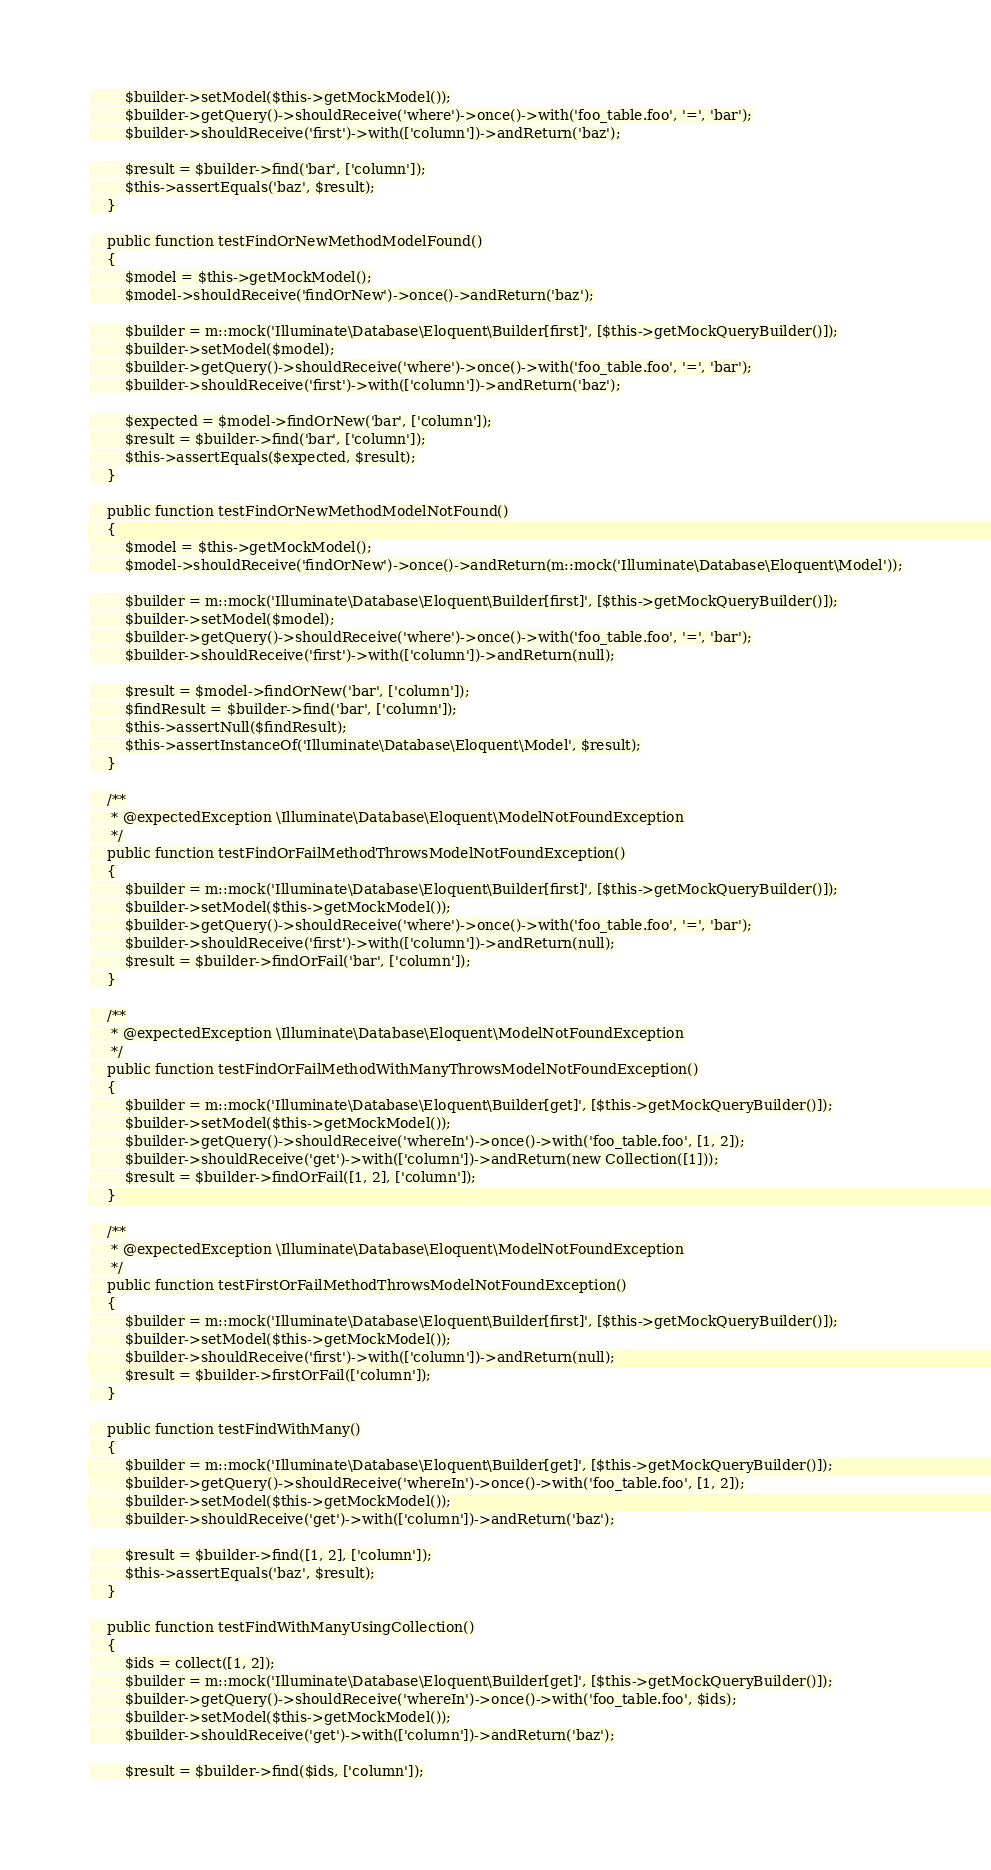<code> <loc_0><loc_0><loc_500><loc_500><_PHP_>        $builder->setModel($this->getMockModel());
        $builder->getQuery()->shouldReceive('where')->once()->with('foo_table.foo', '=', 'bar');
        $builder->shouldReceive('first')->with(['column'])->andReturn('baz');

        $result = $builder->find('bar', ['column']);
        $this->assertEquals('baz', $result);
    }

    public function testFindOrNewMethodModelFound()
    {
        $model = $this->getMockModel();
        $model->shouldReceive('findOrNew')->once()->andReturn('baz');

        $builder = m::mock('Illuminate\Database\Eloquent\Builder[first]', [$this->getMockQueryBuilder()]);
        $builder->setModel($model);
        $builder->getQuery()->shouldReceive('where')->once()->with('foo_table.foo', '=', 'bar');
        $builder->shouldReceive('first')->with(['column'])->andReturn('baz');

        $expected = $model->findOrNew('bar', ['column']);
        $result = $builder->find('bar', ['column']);
        $this->assertEquals($expected, $result);
    }

    public function testFindOrNewMethodModelNotFound()
    {
        $model = $this->getMockModel();
        $model->shouldReceive('findOrNew')->once()->andReturn(m::mock('Illuminate\Database\Eloquent\Model'));

        $builder = m::mock('Illuminate\Database\Eloquent\Builder[first]', [$this->getMockQueryBuilder()]);
        $builder->setModel($model);
        $builder->getQuery()->shouldReceive('where')->once()->with('foo_table.foo', '=', 'bar');
        $builder->shouldReceive('first')->with(['column'])->andReturn(null);

        $result = $model->findOrNew('bar', ['column']);
        $findResult = $builder->find('bar', ['column']);
        $this->assertNull($findResult);
        $this->assertInstanceOf('Illuminate\Database\Eloquent\Model', $result);
    }

    /**
     * @expectedException \Illuminate\Database\Eloquent\ModelNotFoundException
     */
    public function testFindOrFailMethodThrowsModelNotFoundException()
    {
        $builder = m::mock('Illuminate\Database\Eloquent\Builder[first]', [$this->getMockQueryBuilder()]);
        $builder->setModel($this->getMockModel());
        $builder->getQuery()->shouldReceive('where')->once()->with('foo_table.foo', '=', 'bar');
        $builder->shouldReceive('first')->with(['column'])->andReturn(null);
        $result = $builder->findOrFail('bar', ['column']);
    }

    /**
     * @expectedException \Illuminate\Database\Eloquent\ModelNotFoundException
     */
    public function testFindOrFailMethodWithManyThrowsModelNotFoundException()
    {
        $builder = m::mock('Illuminate\Database\Eloquent\Builder[get]', [$this->getMockQueryBuilder()]);
        $builder->setModel($this->getMockModel());
        $builder->getQuery()->shouldReceive('whereIn')->once()->with('foo_table.foo', [1, 2]);
        $builder->shouldReceive('get')->with(['column'])->andReturn(new Collection([1]));
        $result = $builder->findOrFail([1, 2], ['column']);
    }

    /**
     * @expectedException \Illuminate\Database\Eloquent\ModelNotFoundException
     */
    public function testFirstOrFailMethodThrowsModelNotFoundException()
    {
        $builder = m::mock('Illuminate\Database\Eloquent\Builder[first]', [$this->getMockQueryBuilder()]);
        $builder->setModel($this->getMockModel());
        $builder->shouldReceive('first')->with(['column'])->andReturn(null);
        $result = $builder->firstOrFail(['column']);
    }

    public function testFindWithMany()
    {
        $builder = m::mock('Illuminate\Database\Eloquent\Builder[get]', [$this->getMockQueryBuilder()]);
        $builder->getQuery()->shouldReceive('whereIn')->once()->with('foo_table.foo', [1, 2]);
        $builder->setModel($this->getMockModel());
        $builder->shouldReceive('get')->with(['column'])->andReturn('baz');

        $result = $builder->find([1, 2], ['column']);
        $this->assertEquals('baz', $result);
    }

    public function testFindWithManyUsingCollection()
    {
        $ids = collect([1, 2]);
        $builder = m::mock('Illuminate\Database\Eloquent\Builder[get]', [$this->getMockQueryBuilder()]);
        $builder->getQuery()->shouldReceive('whereIn')->once()->with('foo_table.foo', $ids);
        $builder->setModel($this->getMockModel());
        $builder->shouldReceive('get')->with(['column'])->andReturn('baz');

        $result = $builder->find($ids, ['column']);</code> 